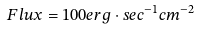<formula> <loc_0><loc_0><loc_500><loc_500>F l u x = 1 0 0 e r g \cdot s e c ^ { - 1 } c m ^ { - 2 }</formula> 